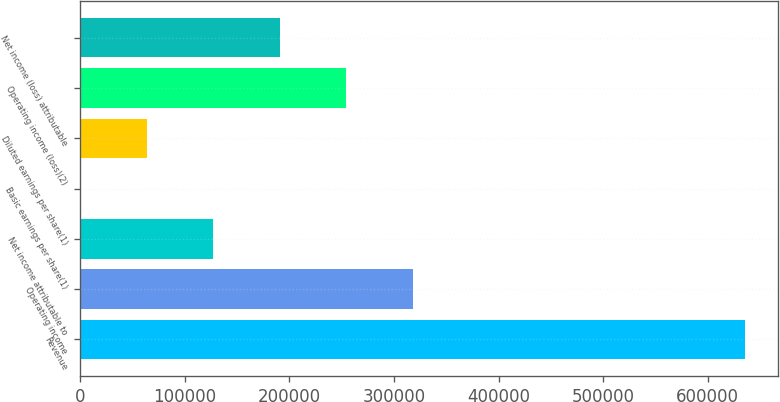Convert chart to OTSL. <chart><loc_0><loc_0><loc_500><loc_500><bar_chart><fcel>Revenue<fcel>Operating income<fcel>Net income attributable to<fcel>Basic earnings per share(1)<fcel>Diluted earnings per share(1)<fcel>Operating income (loss)(2)<fcel>Net income (loss) attributable<nl><fcel>635712<fcel>317856<fcel>127143<fcel>0.14<fcel>63571.3<fcel>254285<fcel>190714<nl></chart> 